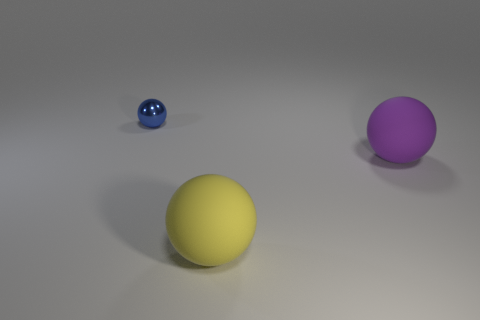Add 1 metal spheres. How many objects exist? 4 Add 1 large matte balls. How many large matte balls are left? 3 Add 2 balls. How many balls exist? 5 Subtract 0 cyan cylinders. How many objects are left? 3 Subtract all small cubes. Subtract all yellow matte balls. How many objects are left? 2 